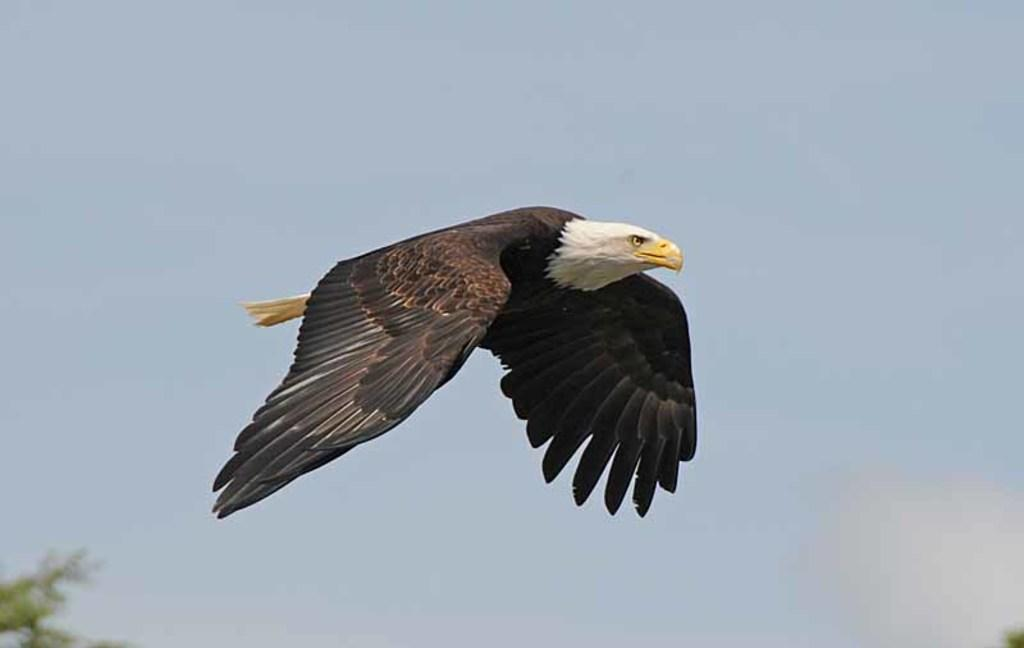What type of animal is present in the image? There is a bird in the image. What is the bird doing in the image? The bird is flying in the sky. What can be seen in the background of the image? There are leaves visible in the background of the image. Can you see the tiger wearing a crown in the image? There is no tiger or crown present in the image; it features a bird flying in the sky with leaves visible in the background. 